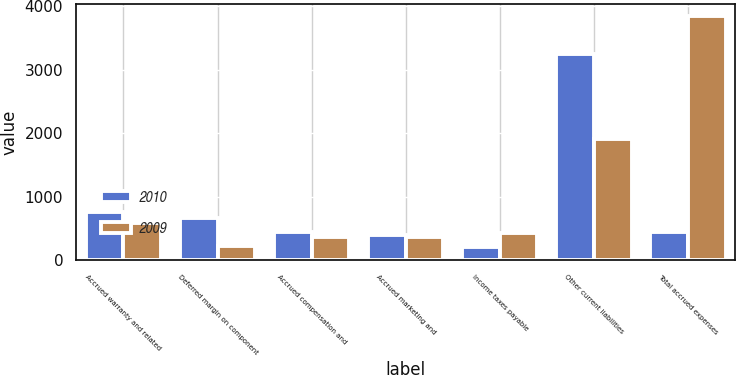Convert chart to OTSL. <chart><loc_0><loc_0><loc_500><loc_500><stacked_bar_chart><ecel><fcel>Accrued warranty and related<fcel>Deferred margin on component<fcel>Accrued compensation and<fcel>Accrued marketing and<fcel>Income taxes payable<fcel>Other current liabilities<fcel>Total accrued expenses<nl><fcel>2010<fcel>761<fcel>663<fcel>436<fcel>396<fcel>210<fcel>3257<fcel>436<nl><fcel>2009<fcel>577<fcel>225<fcel>357<fcel>359<fcel>430<fcel>1904<fcel>3852<nl></chart> 